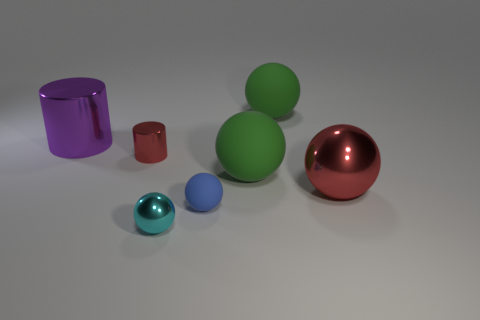What can you infer about the lighting in this scene? The lighting appears to come from above, casting soft shadows directly underneath each object. The bright, even illumination accentuates the shiny texture of the objects and contributes to the highlights on their curves and edges, indicating a controlled indoor setting, likely crafted for a 3D rendering. 